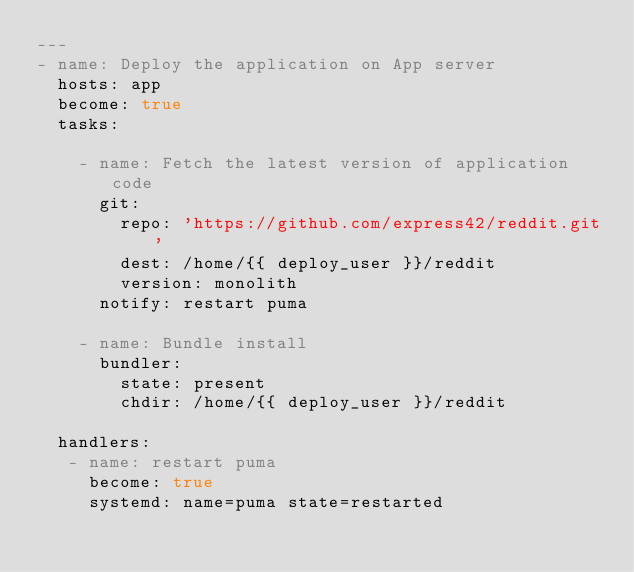Convert code to text. <code><loc_0><loc_0><loc_500><loc_500><_YAML_>---
- name: Deploy the application on App server
  hosts: app
  become: true
  tasks:

    - name: Fetch the latest version of application code
      git:
        repo: 'https://github.com/express42/reddit.git'
        dest: /home/{{ deploy_user }}/reddit
        version: monolith
      notify: restart puma

    - name: Bundle install
      bundler:
        state: present
        chdir: /home/{{ deploy_user }}/reddit

  handlers:
   - name: restart puma
     become: true
     systemd: name=puma state=restarted

</code> 